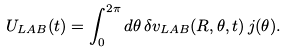Convert formula to latex. <formula><loc_0><loc_0><loc_500><loc_500>U _ { L A B } ( t ) = \int ^ { 2 \pi } _ { 0 } d \theta \, \delta v _ { L A B } ( R , \theta , t ) \, j ( \theta ) .</formula> 